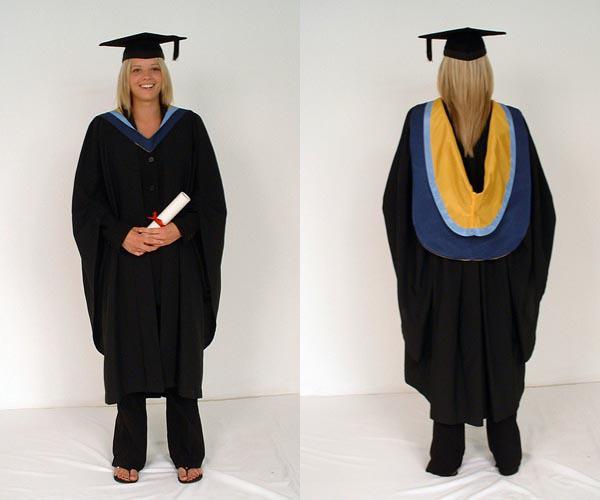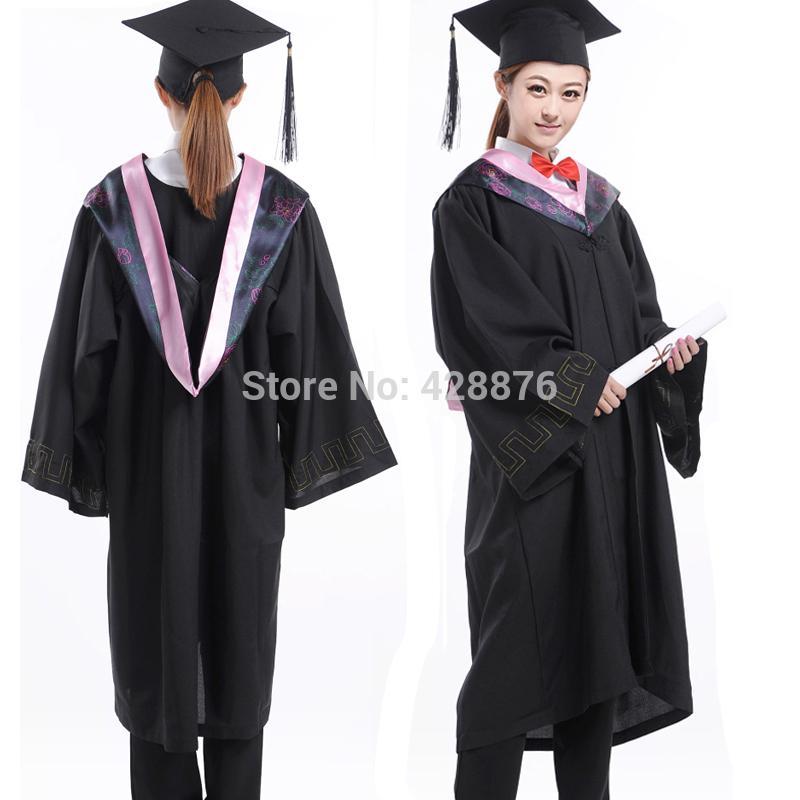The first image is the image on the left, the second image is the image on the right. Evaluate the accuracy of this statement regarding the images: "One out of four graduates has her back turned towards the camera.". Is it true? Answer yes or no. No. The first image is the image on the left, the second image is the image on the right. Analyze the images presented: Is the assertion "In one image, a graduation gown model is wearing silver high heeled shoes." valid? Answer yes or no. No. 